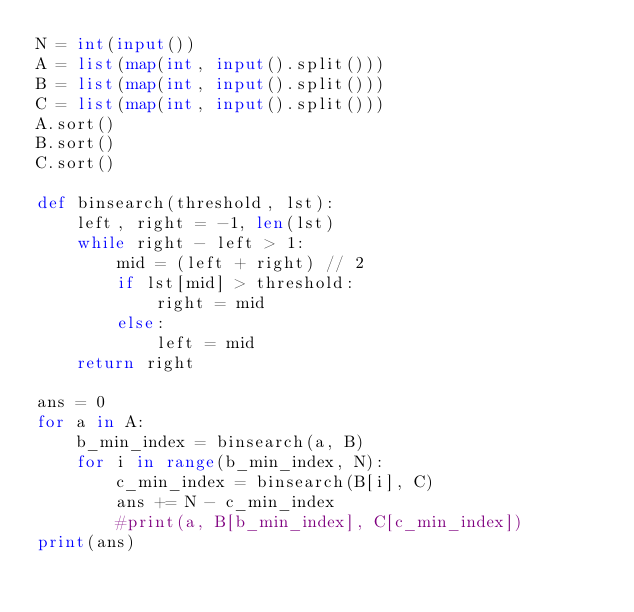<code> <loc_0><loc_0><loc_500><loc_500><_Python_>N = int(input())
A = list(map(int, input().split()))
B = list(map(int, input().split()))
C = list(map(int, input().split()))
A.sort()
B.sort()
C.sort()

def binsearch(threshold, lst):
    left, right = -1, len(lst)
    while right - left > 1:
        mid = (left + right) // 2
        if lst[mid] > threshold:
            right = mid
        else:
            left = mid
    return right

ans = 0
for a in A:
    b_min_index = binsearch(a, B)
    for i in range(b_min_index, N):
        c_min_index = binsearch(B[i], C)
        ans += N - c_min_index
        #print(a, B[b_min_index], C[c_min_index])
print(ans)
</code> 